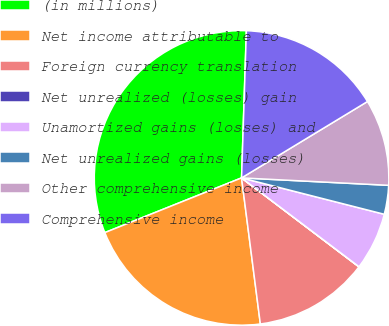<chart> <loc_0><loc_0><loc_500><loc_500><pie_chart><fcel>(in millions)<fcel>Net income attributable to<fcel>Foreign currency translation<fcel>Net unrealized (losses) gain<fcel>Unamortized gains (losses) and<fcel>Net unrealized gains (losses)<fcel>Other comprehensive income<fcel>Comprehensive income<nl><fcel>31.58%<fcel>20.98%<fcel>12.64%<fcel>0.02%<fcel>6.33%<fcel>3.17%<fcel>9.48%<fcel>15.8%<nl></chart> 